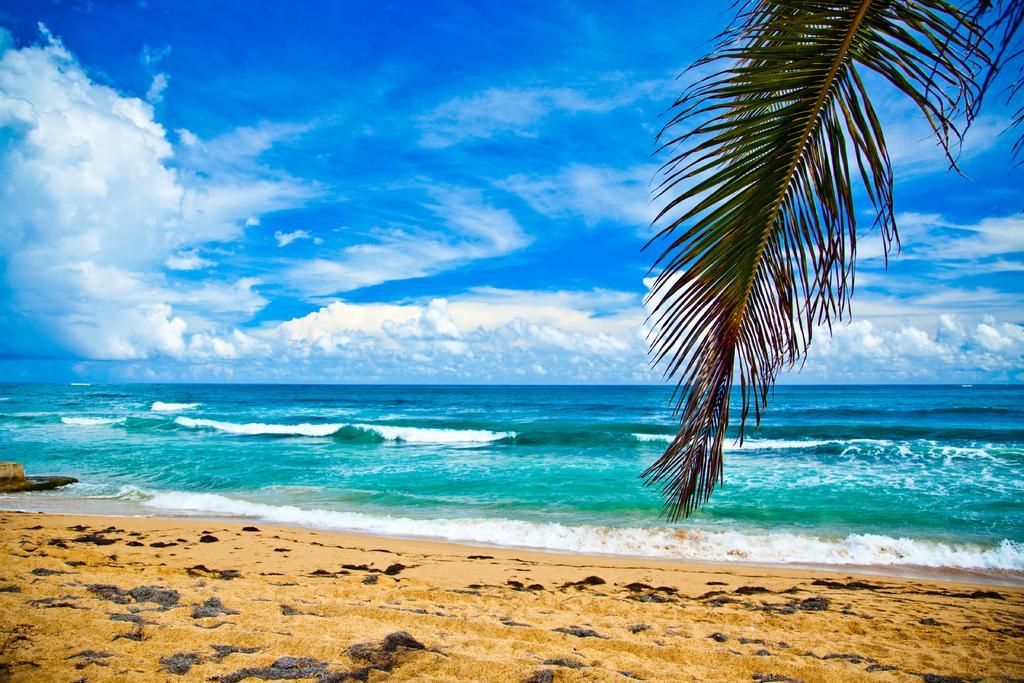How would you summarize this image in a sentence or two? In this image there is the sky towards the top of the image, there are clouds in the sky, there is water, there is sand towards the bottom of the image, there is an object towards the left of the image, there are coconut tree leaves towards the top of the image. 